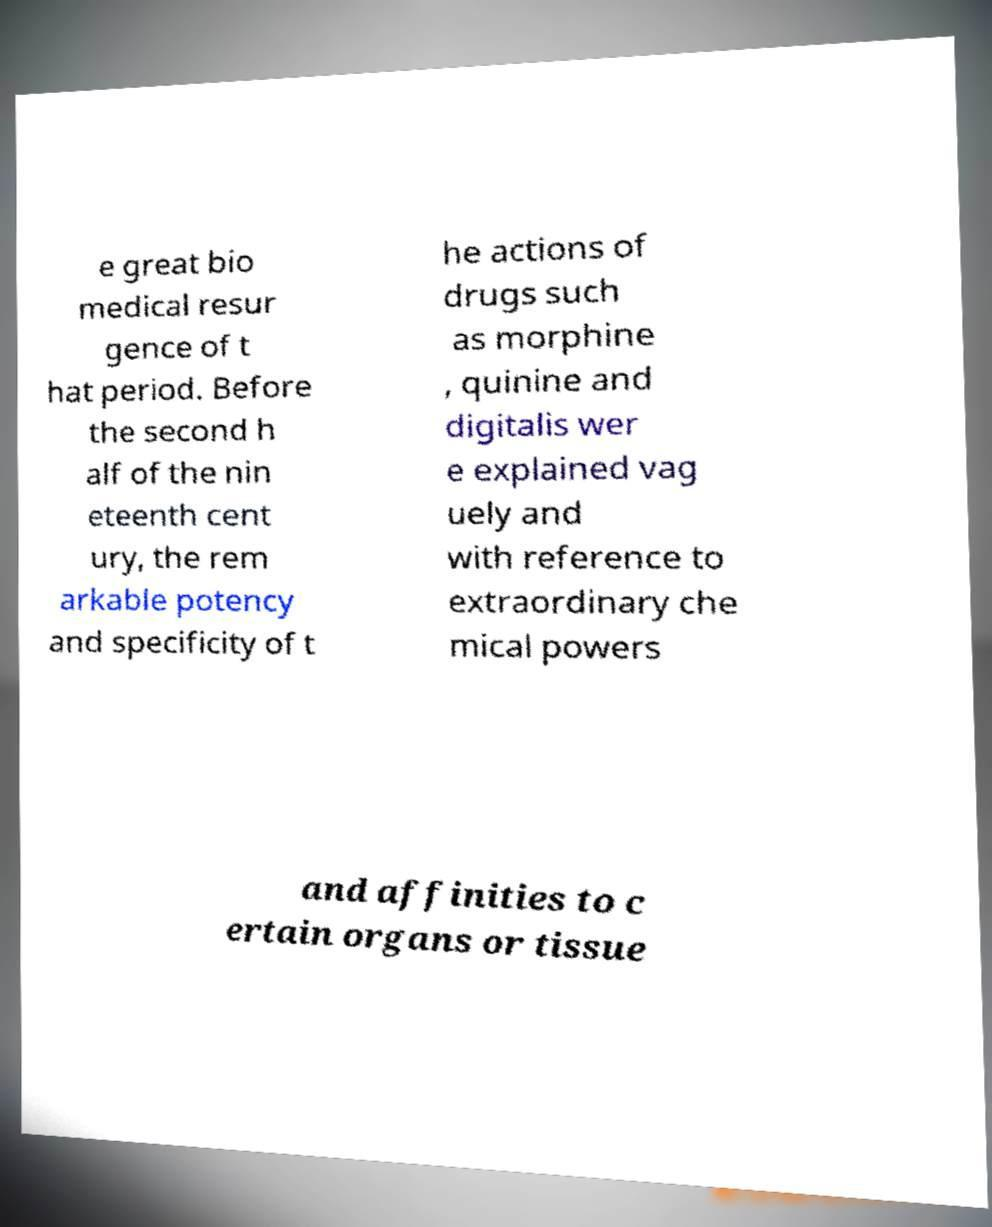I need the written content from this picture converted into text. Can you do that? e great bio medical resur gence of t hat period. Before the second h alf of the nin eteenth cent ury, the rem arkable potency and specificity of t he actions of drugs such as morphine , quinine and digitalis wer e explained vag uely and with reference to extraordinary che mical powers and affinities to c ertain organs or tissue 